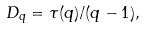<formula> <loc_0><loc_0><loc_500><loc_500>D _ { q } = \tau ( q ) / ( q - 1 ) ,</formula> 